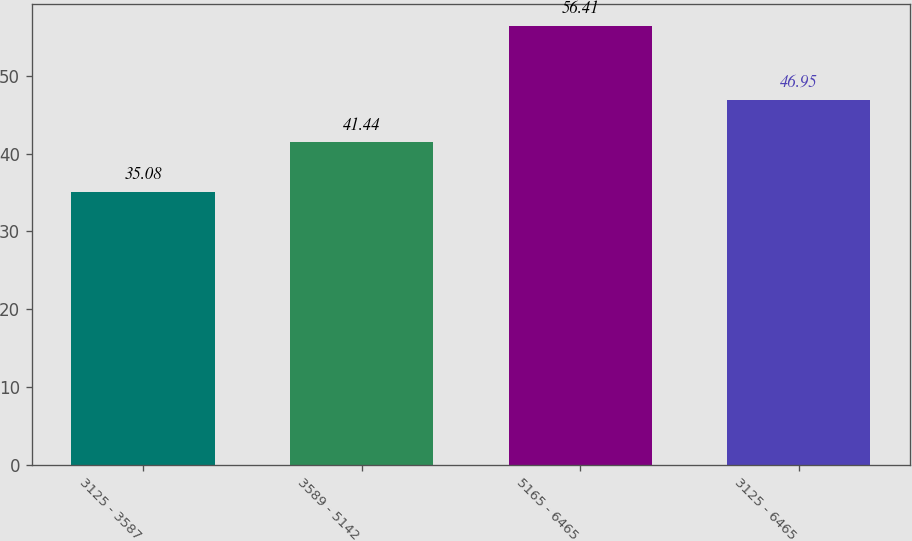<chart> <loc_0><loc_0><loc_500><loc_500><bar_chart><fcel>3125 - 3587<fcel>3589 - 5142<fcel>5165 - 6465<fcel>3125 - 6465<nl><fcel>35.08<fcel>41.44<fcel>56.41<fcel>46.95<nl></chart> 